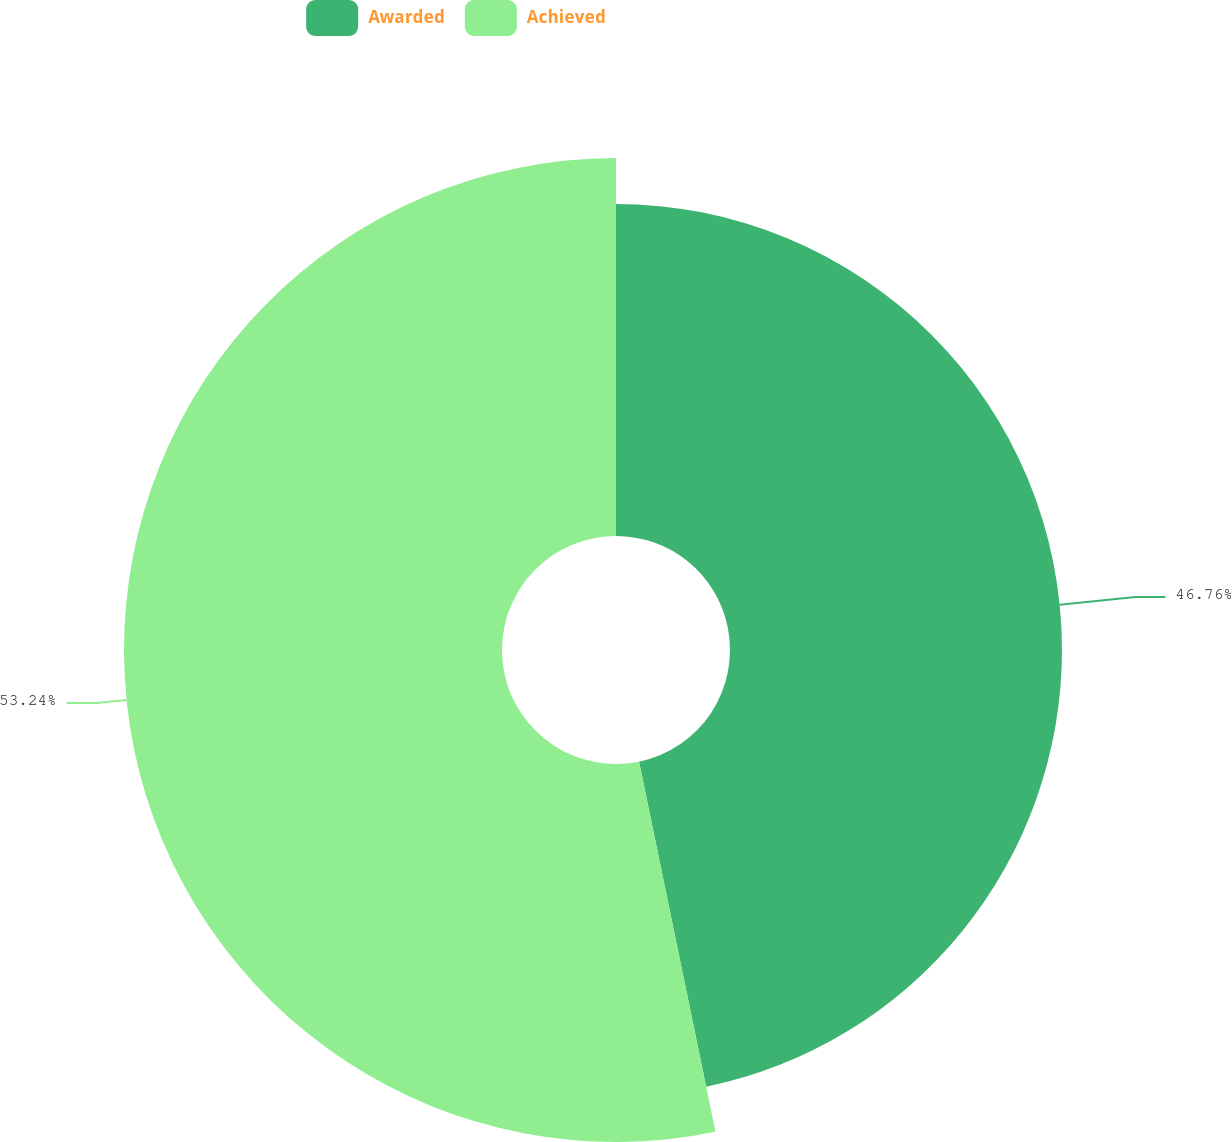Convert chart to OTSL. <chart><loc_0><loc_0><loc_500><loc_500><pie_chart><fcel>Awarded<fcel>Achieved<nl><fcel>46.76%<fcel>53.24%<nl></chart> 